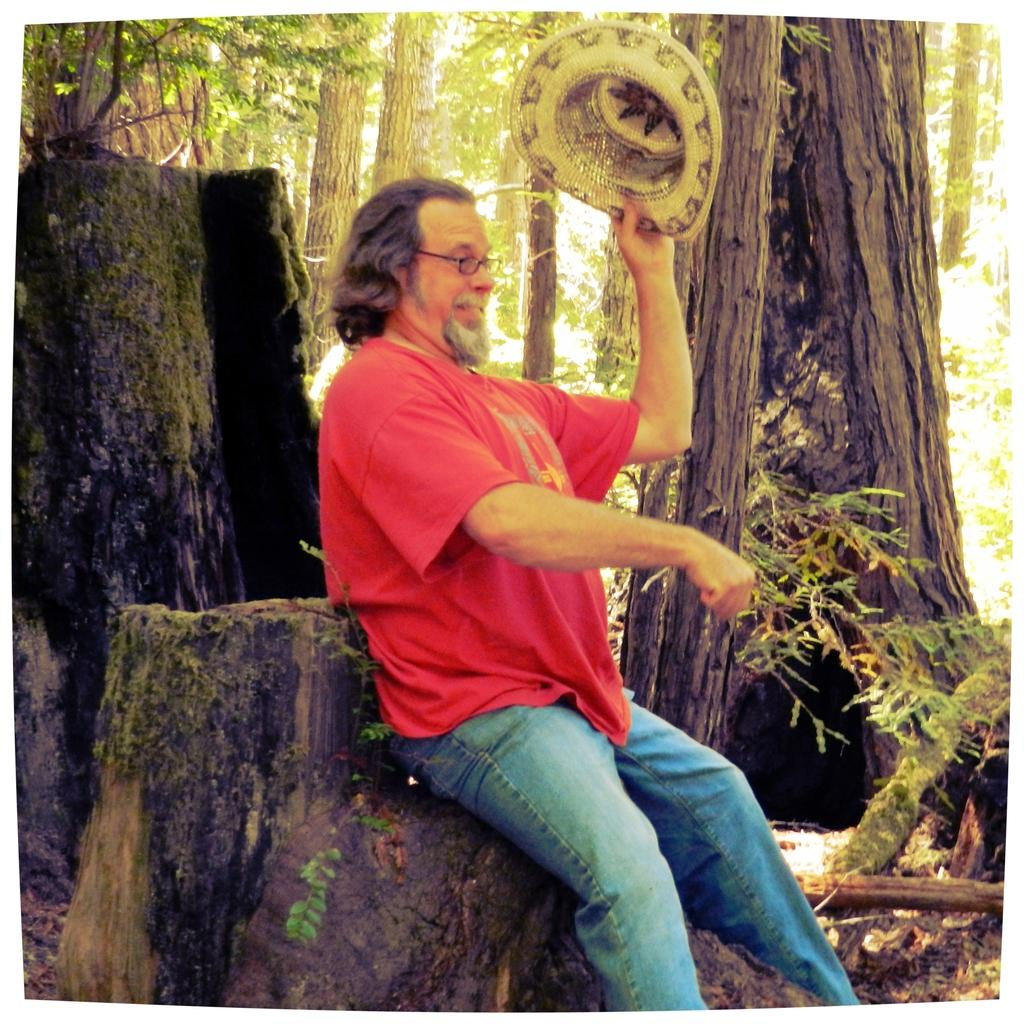What is the man doing in the image? The man is sitting on a trunk in the image. In which direction is the man facing? The man is facing towards the right side. What is the man holding in his hand? The man is holding a cap in his hand. What can be seen in the background of the image? There are many trees in the background of the image. How many lizards are crawling on the man's shoulder in the image? There are no lizards present in the image. What type of bubble is floating near the man's head in the image? There is no bubble present in the image. 